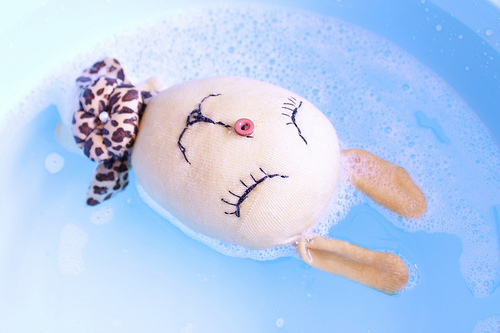<image>
Is there a bunny in front of the water? No. The bunny is not in front of the water. The spatial positioning shows a different relationship between these objects. 